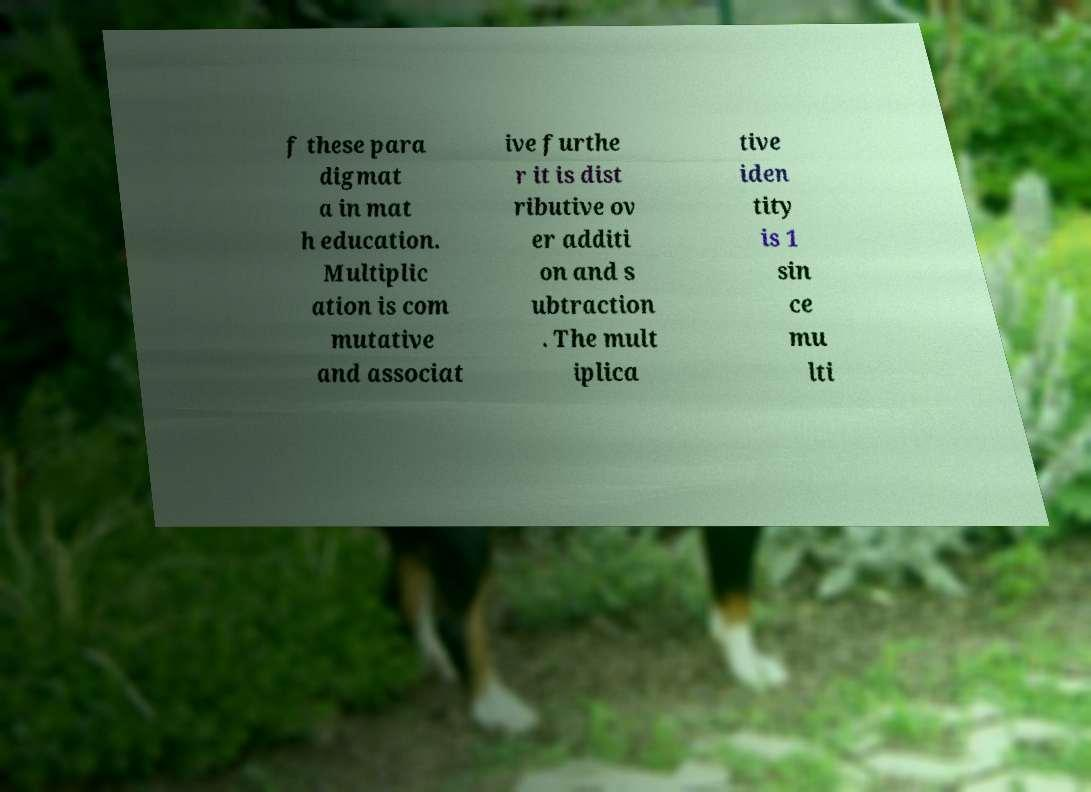Can you read and provide the text displayed in the image?This photo seems to have some interesting text. Can you extract and type it out for me? f these para digmat a in mat h education. Multiplic ation is com mutative and associat ive furthe r it is dist ributive ov er additi on and s ubtraction . The mult iplica tive iden tity is 1 sin ce mu lti 